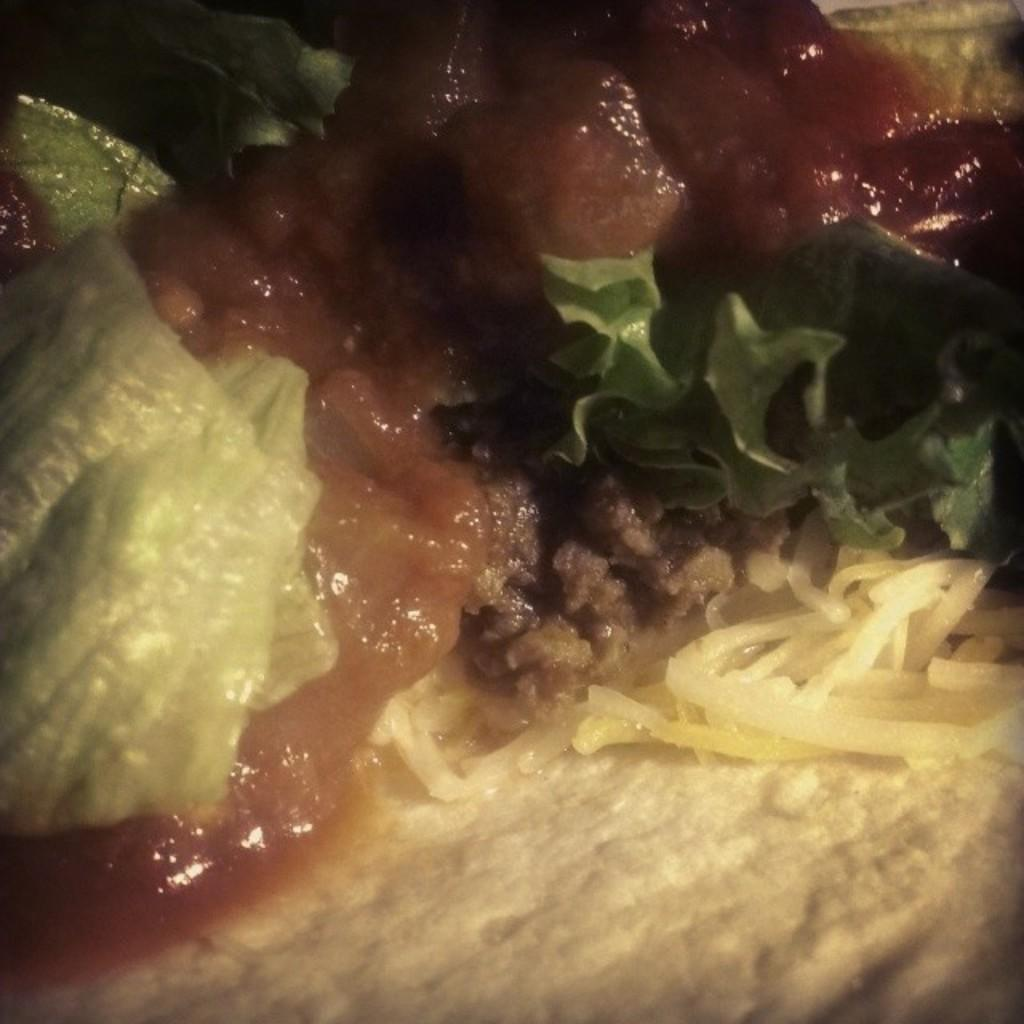What is present in the image? There is food in the image. What type of card can be seen in the image? There is no card present in the image; it only contains food. 